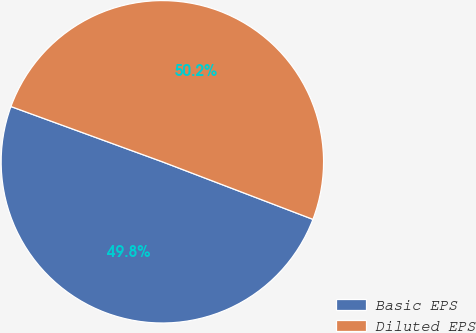<chart> <loc_0><loc_0><loc_500><loc_500><pie_chart><fcel>Basic EPS<fcel>Diluted EPS<nl><fcel>49.76%<fcel>50.24%<nl></chart> 